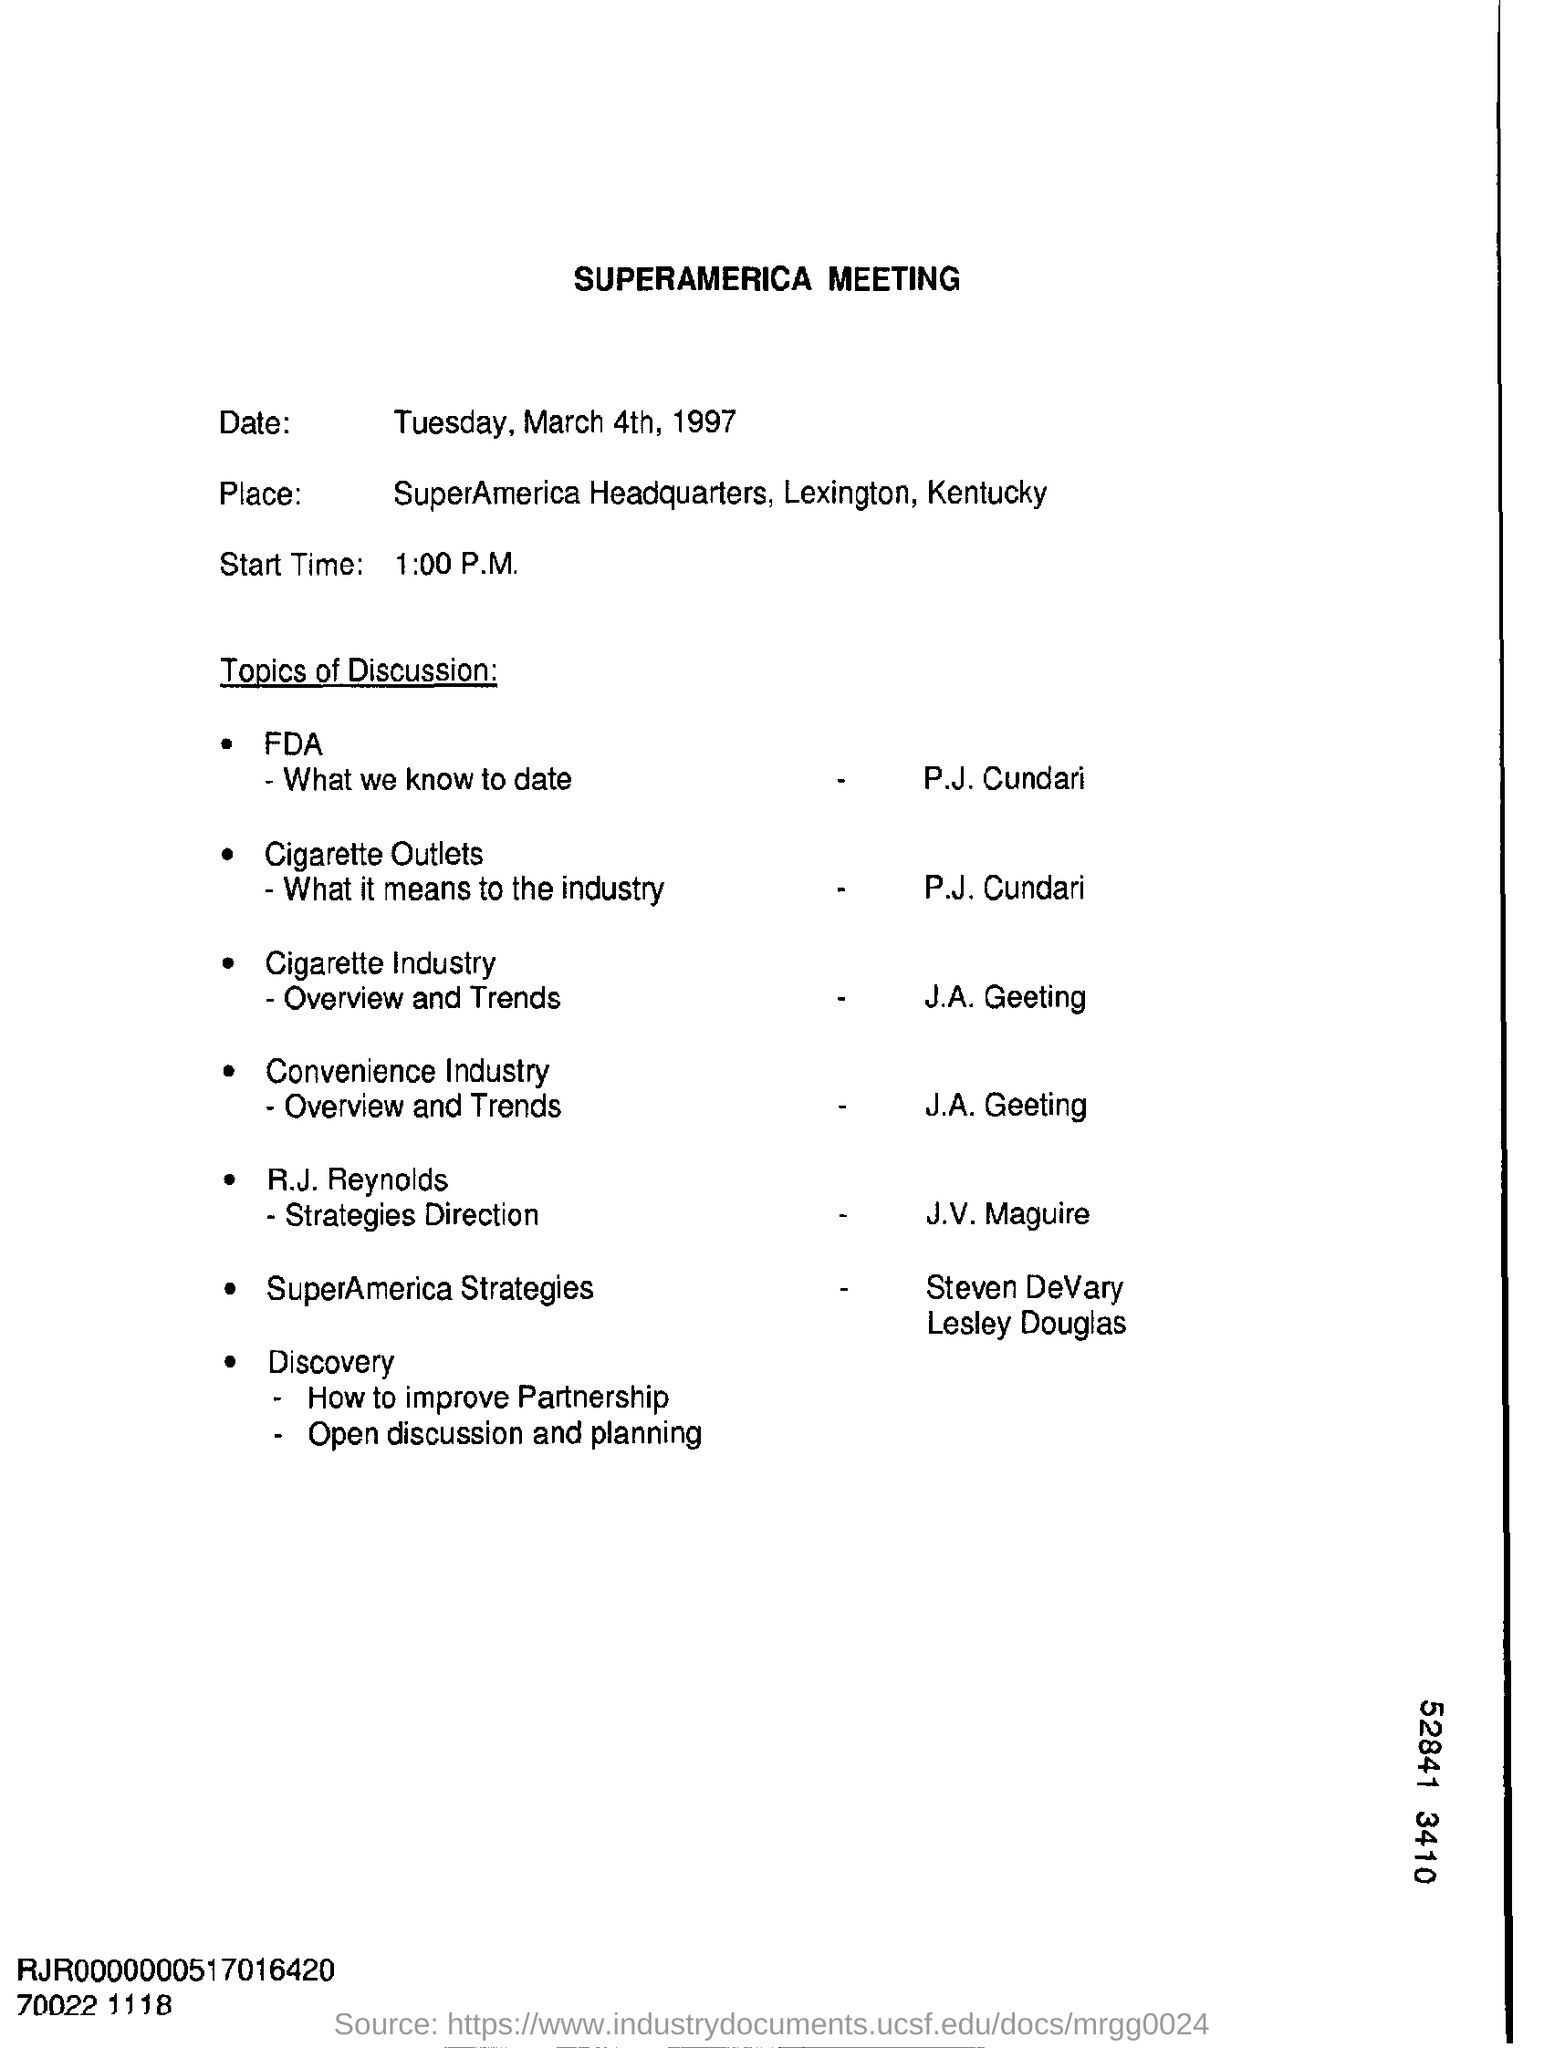Specify some key components in this picture. The start time mentioned in the document is 1:00 P.M. 